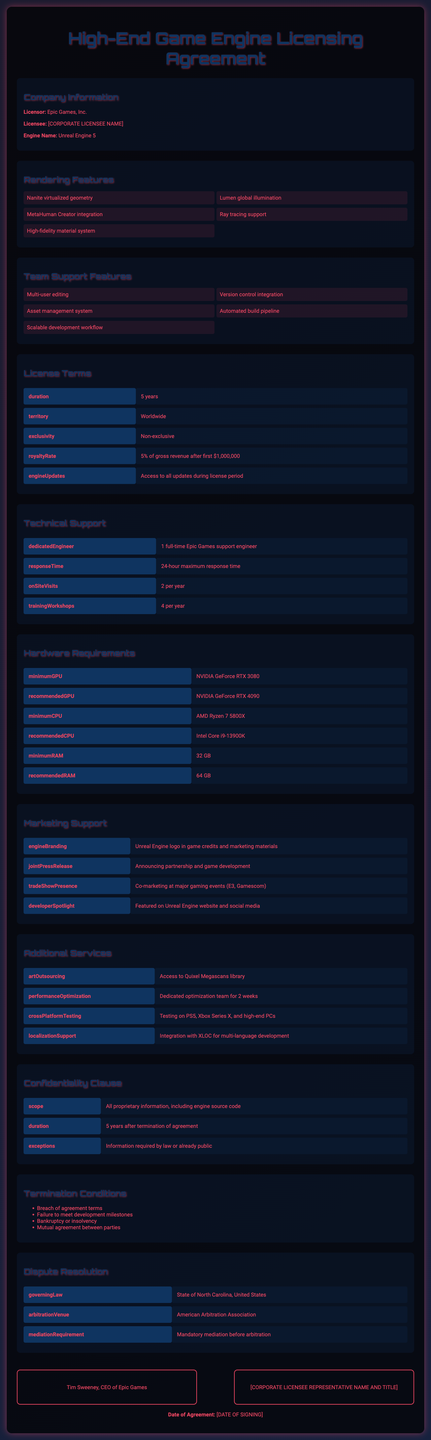What is the license duration? The duration of the license is specified in the license terms section of the document.
Answer: 5 years Who is the licensor? The licensor is the company providing the game engine and is stated in the company information section.
Answer: Epic Games, Inc What feature supports high-fidelity graphics? The document lists several rendering features, one of which supports advanced graphics capabilities.
Answer: Nanite virtualized geometry How many onsite visits are included per year? The number of onsite visits is mentioned under the technical support section of the document.
Answer: 2 per year What is the royalty rate? The royalty rate for the license is disclosed in the license terms section of the form.
Answer: 5% of gross revenue after first $1,000,000 How many training workshops are provided annually? The number of training workshops available each year is indicated in the technical support section.
Answer: 4 per year What is the minimum RAM requirement? The document specifies hardware requirements, including the minimum amount of RAM needed to run the engine.
Answer: 32 GB Which marketing support involves presence at major events? The specific marketing support that includes co-marketing activities is listed in the marketing support section.
Answer: TradeShowPresence What happens if there is a breach of agreement? The document outlines termination conditions, including the consequences of breaching the agreement.
Answer: Termination of agreement 